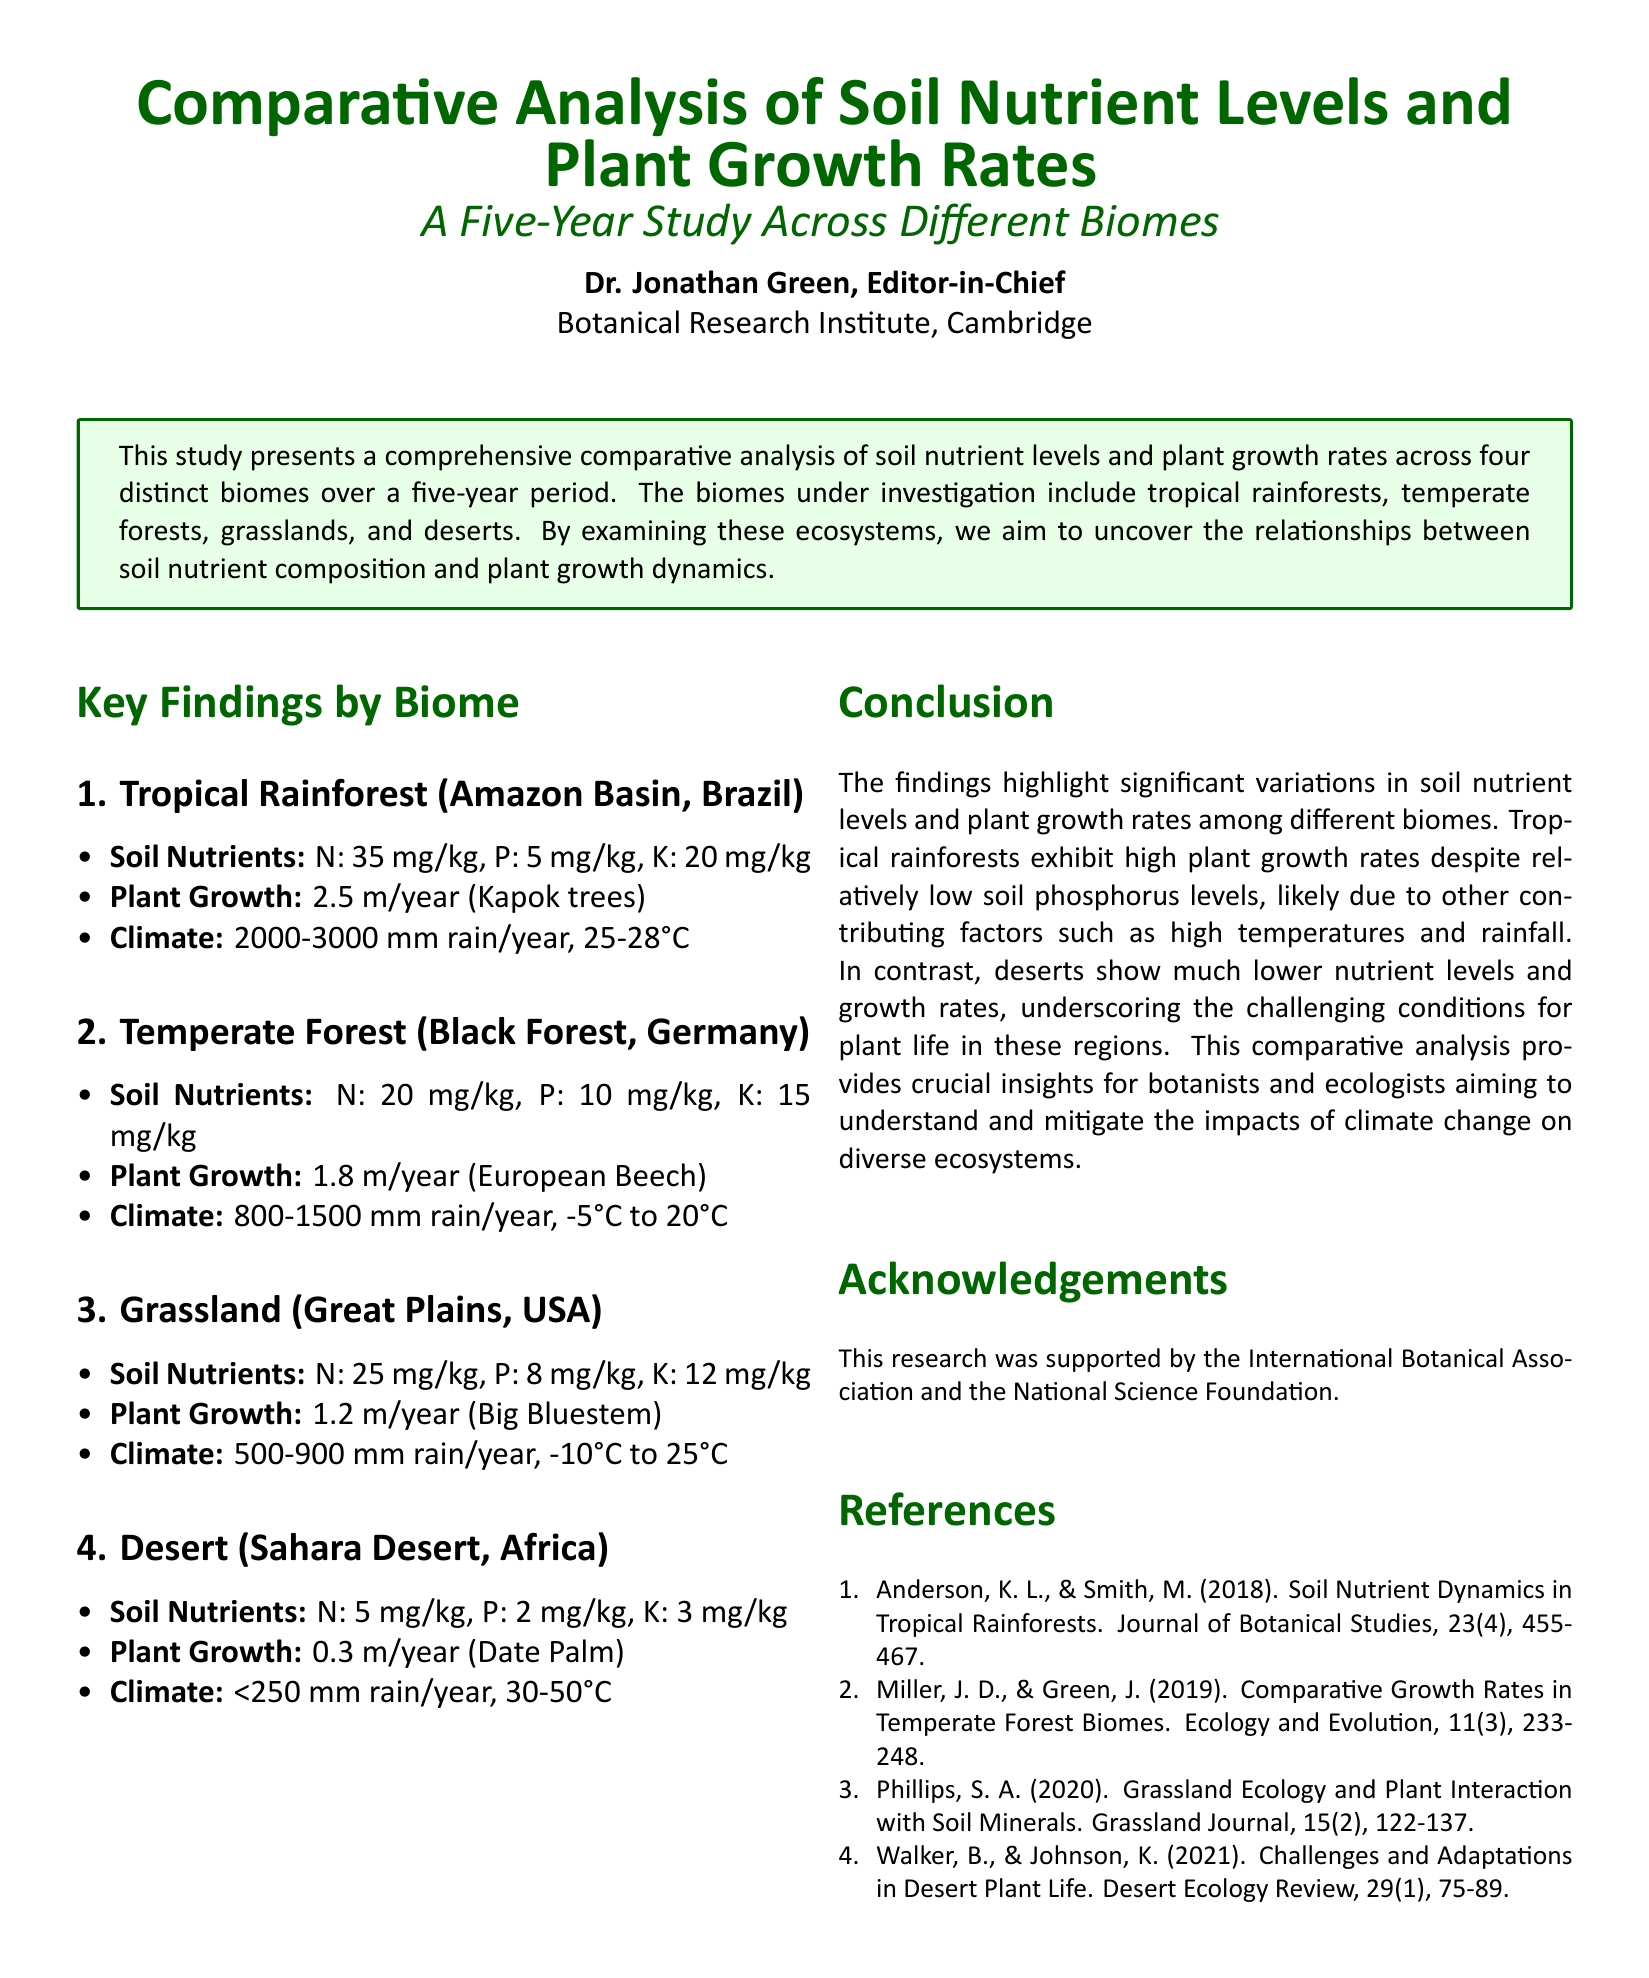What are the soil nitrogen levels in tropical rainforests? The soil nitrogen level in tropical rainforests is specified as 35 mg/kg in the document.
Answer: 35 mg/kg What is the average plant growth rate in deserts? The average plant growth rate in deserts is mentioned as 0.3 m/year for Date Palm.
Answer: 0.3 m/year Which biome has the highest plant growth rate? The document states that tropical rainforests exhibit the highest plant growth rate at 2.5 m/year.
Answer: 2.5 m/year What is the climate range in the Great Plains? The document specifies the climate range in the Great Plains as -10°C to 25°C.
Answer: -10°C to 25°C How does the soil phosphorus level compare between tropical rainforests and temperate forests? The phosphorus level in tropical rainforests is 5 mg/kg, while in temperate forests it is 10 mg/kg, indicating that temperate forests have higher phosphorus levels.
Answer: Higher in temperate forests What trend is observed in soil nutrient levels as one moves from tropical rainforests to deserts? The trend shows a decline in soil nutrient levels from tropical rainforests to deserts, as described in the findings.
Answer: Decline in nutrient levels What is the purpose of this five-year study? The purpose of the five-year study is to uncover relationships between soil nutrient composition and plant growth dynamics across different biomes.
Answer: To uncover relationships Who supported the research reported in the document? The research was supported by the International Botanical Association and the National Science Foundation as listed in the acknowledgements.
Answer: International Botanical Association and National Science Foundation Which tree is associated with the average growth rate in temperate forests? The European Beech is the species mentioned related to the average growth rate in temperate forests.
Answer: European Beech What significant challenge for plant life is highlighted in the conclusion regarding deserts? The document emphasizes the challenging conditions of low soil nutrient levels and growth rates in deserts.
Answer: Low soil nutrient levels and growth rates 